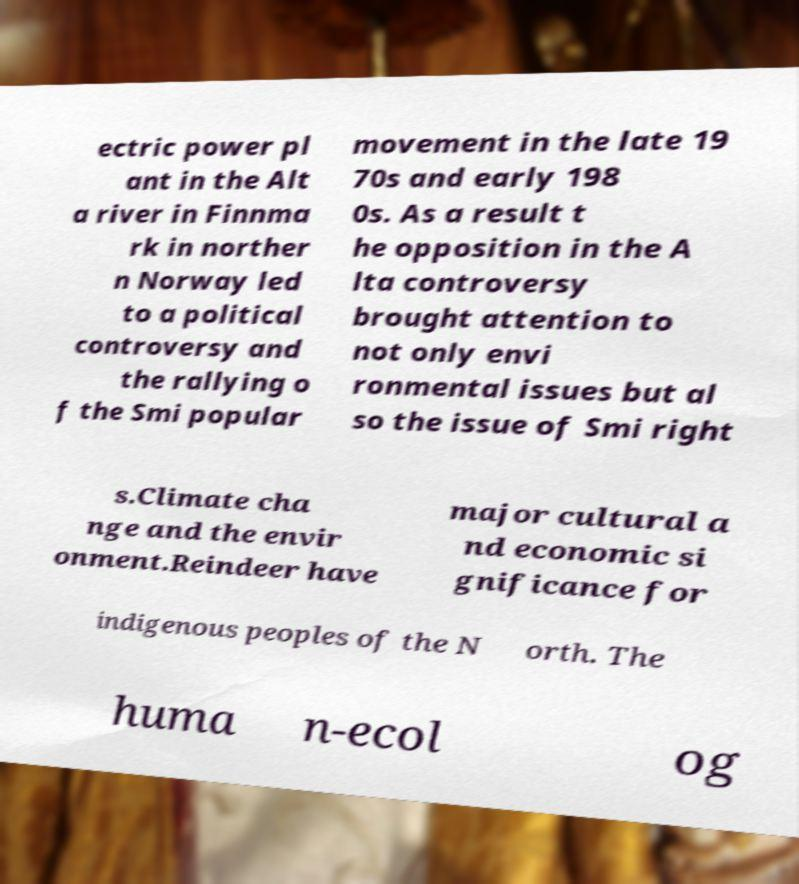Can you read and provide the text displayed in the image?This photo seems to have some interesting text. Can you extract and type it out for me? ectric power pl ant in the Alt a river in Finnma rk in norther n Norway led to a political controversy and the rallying o f the Smi popular movement in the late 19 70s and early 198 0s. As a result t he opposition in the A lta controversy brought attention to not only envi ronmental issues but al so the issue of Smi right s.Climate cha nge and the envir onment.Reindeer have major cultural a nd economic si gnificance for indigenous peoples of the N orth. The huma n-ecol og 